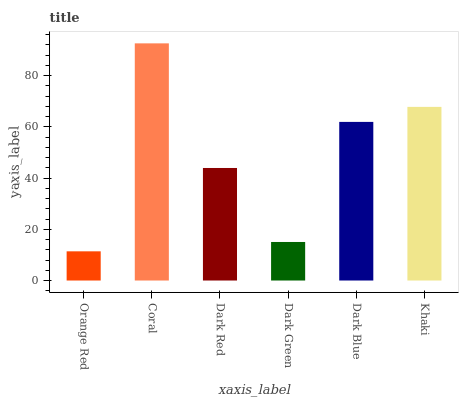Is Orange Red the minimum?
Answer yes or no. Yes. Is Coral the maximum?
Answer yes or no. Yes. Is Dark Red the minimum?
Answer yes or no. No. Is Dark Red the maximum?
Answer yes or no. No. Is Coral greater than Dark Red?
Answer yes or no. Yes. Is Dark Red less than Coral?
Answer yes or no. Yes. Is Dark Red greater than Coral?
Answer yes or no. No. Is Coral less than Dark Red?
Answer yes or no. No. Is Dark Blue the high median?
Answer yes or no. Yes. Is Dark Red the low median?
Answer yes or no. Yes. Is Orange Red the high median?
Answer yes or no. No. Is Orange Red the low median?
Answer yes or no. No. 